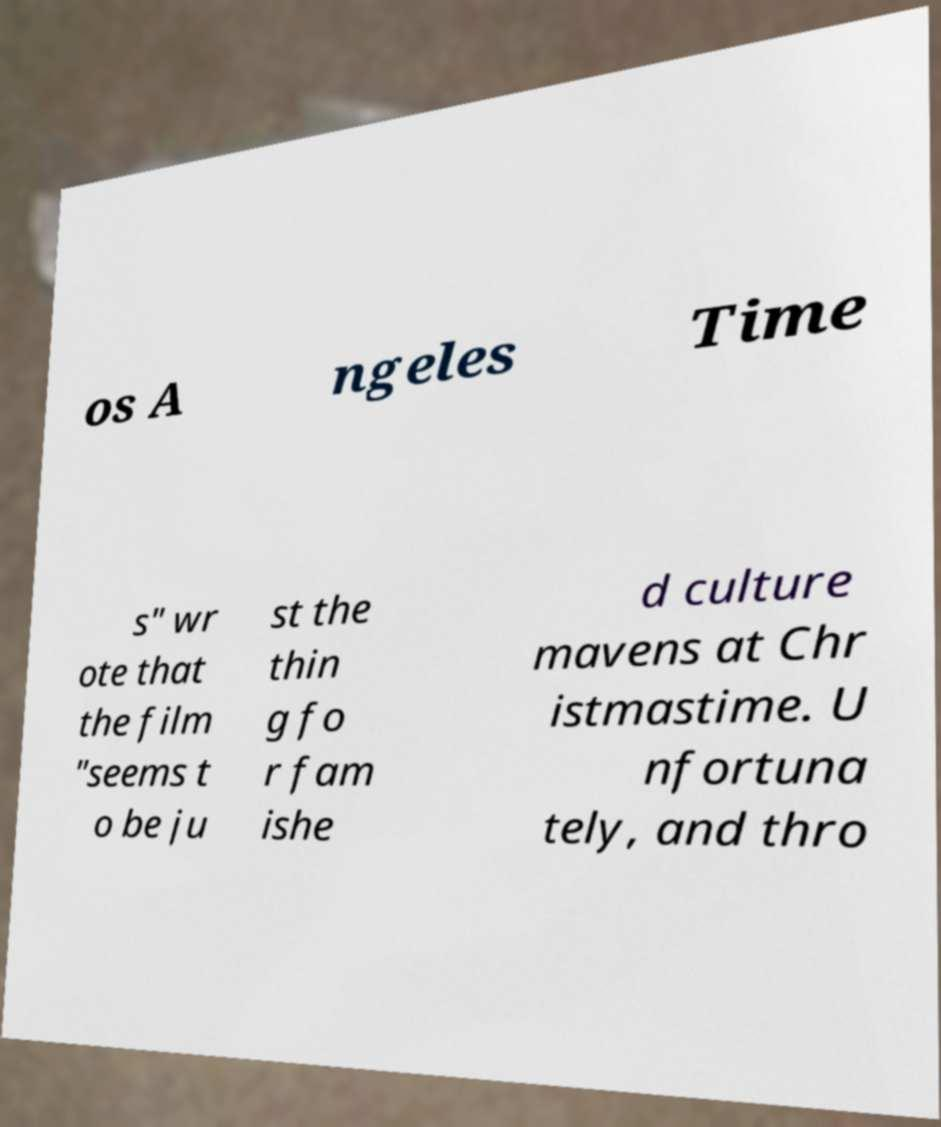What messages or text are displayed in this image? I need them in a readable, typed format. os A ngeles Time s" wr ote that the film "seems t o be ju st the thin g fo r fam ishe d culture mavens at Chr istmastime. U nfortuna tely, and thro 